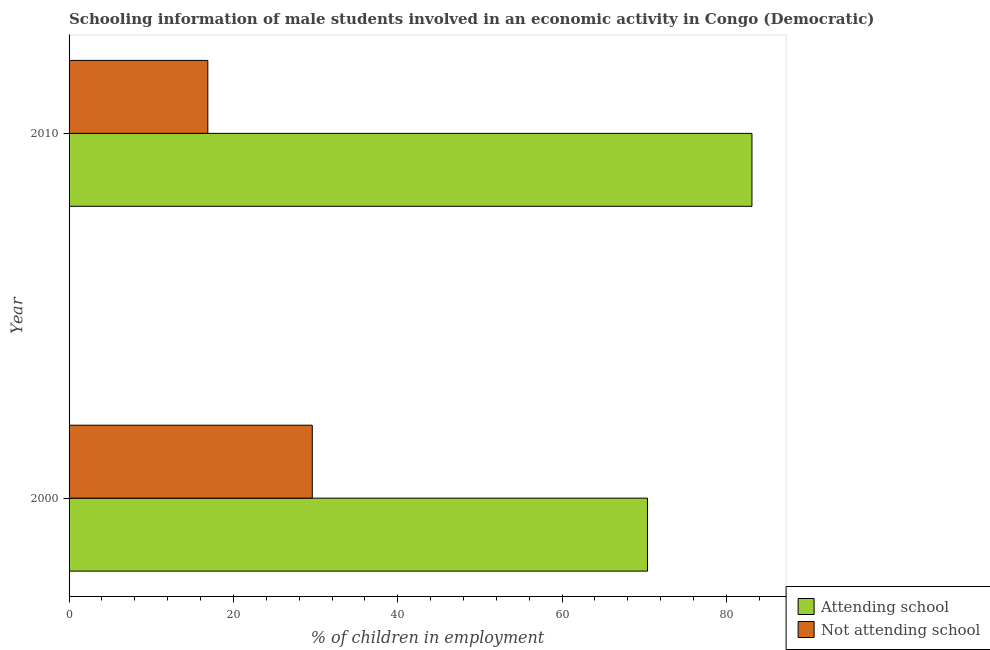How many bars are there on the 2nd tick from the top?
Make the answer very short. 2. What is the percentage of employed males who are attending school in 2010?
Your response must be concise. 83.11. Across all years, what is the maximum percentage of employed males who are not attending school?
Keep it short and to the point. 29.6. Across all years, what is the minimum percentage of employed males who are not attending school?
Offer a very short reply. 16.89. In which year was the percentage of employed males who are attending school maximum?
Your response must be concise. 2010. What is the total percentage of employed males who are attending school in the graph?
Offer a terse response. 153.51. What is the difference between the percentage of employed males who are attending school in 2000 and that in 2010?
Ensure brevity in your answer.  -12.71. What is the difference between the percentage of employed males who are attending school in 2010 and the percentage of employed males who are not attending school in 2000?
Your answer should be compact. 53.51. What is the average percentage of employed males who are attending school per year?
Keep it short and to the point. 76.76. In the year 2000, what is the difference between the percentage of employed males who are not attending school and percentage of employed males who are attending school?
Keep it short and to the point. -40.8. In how many years, is the percentage of employed males who are not attending school greater than 52 %?
Ensure brevity in your answer.  0. What is the ratio of the percentage of employed males who are not attending school in 2000 to that in 2010?
Provide a short and direct response. 1.75. What does the 2nd bar from the top in 2010 represents?
Offer a terse response. Attending school. What does the 1st bar from the bottom in 2010 represents?
Provide a short and direct response. Attending school. How many bars are there?
Keep it short and to the point. 4. Are all the bars in the graph horizontal?
Offer a terse response. Yes. How many years are there in the graph?
Ensure brevity in your answer.  2. What is the difference between two consecutive major ticks on the X-axis?
Your answer should be compact. 20. Does the graph contain grids?
Provide a short and direct response. No. How many legend labels are there?
Ensure brevity in your answer.  2. How are the legend labels stacked?
Ensure brevity in your answer.  Vertical. What is the title of the graph?
Provide a succinct answer. Schooling information of male students involved in an economic activity in Congo (Democratic). Does "Lower secondary rate" appear as one of the legend labels in the graph?
Provide a short and direct response. No. What is the label or title of the X-axis?
Your answer should be very brief. % of children in employment. What is the label or title of the Y-axis?
Make the answer very short. Year. What is the % of children in employment of Attending school in 2000?
Your answer should be compact. 70.4. What is the % of children in employment of Not attending school in 2000?
Provide a succinct answer. 29.6. What is the % of children in employment in Attending school in 2010?
Your answer should be very brief. 83.11. What is the % of children in employment of Not attending school in 2010?
Your response must be concise. 16.89. Across all years, what is the maximum % of children in employment of Attending school?
Your answer should be very brief. 83.11. Across all years, what is the maximum % of children in employment of Not attending school?
Offer a very short reply. 29.6. Across all years, what is the minimum % of children in employment in Attending school?
Ensure brevity in your answer.  70.4. Across all years, what is the minimum % of children in employment of Not attending school?
Keep it short and to the point. 16.89. What is the total % of children in employment in Attending school in the graph?
Your answer should be very brief. 153.51. What is the total % of children in employment of Not attending school in the graph?
Your response must be concise. 46.49. What is the difference between the % of children in employment of Attending school in 2000 and that in 2010?
Make the answer very short. -12.71. What is the difference between the % of children in employment of Not attending school in 2000 and that in 2010?
Make the answer very short. 12.71. What is the difference between the % of children in employment of Attending school in 2000 and the % of children in employment of Not attending school in 2010?
Give a very brief answer. 53.51. What is the average % of children in employment of Attending school per year?
Offer a very short reply. 76.76. What is the average % of children in employment in Not attending school per year?
Keep it short and to the point. 23.24. In the year 2000, what is the difference between the % of children in employment of Attending school and % of children in employment of Not attending school?
Your answer should be compact. 40.8. In the year 2010, what is the difference between the % of children in employment of Attending school and % of children in employment of Not attending school?
Offer a terse response. 66.23. What is the ratio of the % of children in employment of Attending school in 2000 to that in 2010?
Provide a succinct answer. 0.85. What is the ratio of the % of children in employment of Not attending school in 2000 to that in 2010?
Offer a terse response. 1.75. What is the difference between the highest and the second highest % of children in employment in Attending school?
Your answer should be compact. 12.71. What is the difference between the highest and the second highest % of children in employment in Not attending school?
Provide a succinct answer. 12.71. What is the difference between the highest and the lowest % of children in employment of Attending school?
Your answer should be compact. 12.71. What is the difference between the highest and the lowest % of children in employment in Not attending school?
Keep it short and to the point. 12.71. 